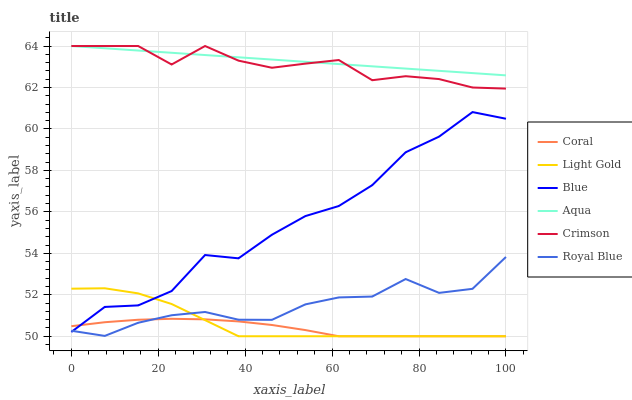Does Aqua have the minimum area under the curve?
Answer yes or no. No. Does Coral have the maximum area under the curve?
Answer yes or no. No. Is Coral the smoothest?
Answer yes or no. No. Is Coral the roughest?
Answer yes or no. No. Does Aqua have the lowest value?
Answer yes or no. No. Does Coral have the highest value?
Answer yes or no. No. Is Royal Blue less than Aqua?
Answer yes or no. Yes. Is Crimson greater than Royal Blue?
Answer yes or no. Yes. Does Royal Blue intersect Aqua?
Answer yes or no. No. 